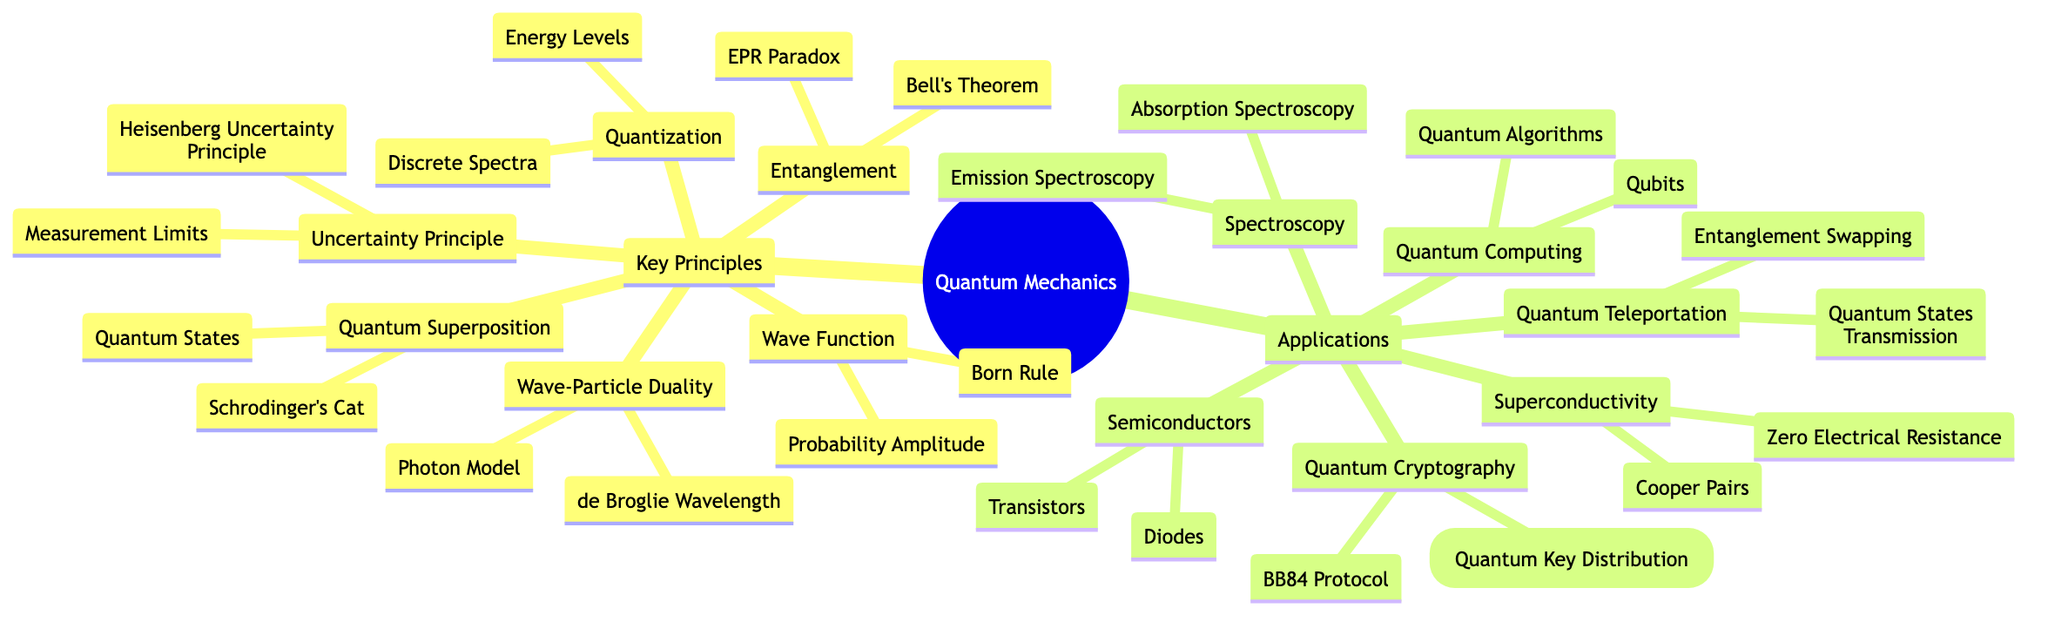What are the key principles of Quantum Mechanics? The top-level category of "Key Principles" includes six distinct principles: Wave-Particle Duality, Uncertainty Principle, Quantum Superposition, Quantization, Entanglement, and Wave Function.
Answer: Wave-Particle Duality, Uncertainty Principle, Quantum Superposition, Quantization, Entanglement, Wave Function How many applications are listed under Quantum Mechanics? The applications can be counted under the "Applications" section. There are six applications mentioned, which are Quantum Computing, Quantum Cryptography, Quantum Teleportation, Semiconductors, Superconductivity, and Spectroscopy.
Answer: Six What is the relationship between Quantum Teleportation and Entanglement? In the diagram, Quantum Teleportation is categorized as an application of Quantum Mechanics, and one of its components is entitled "Entanglement Swapping," which shows that entanglement plays a role in the process of quantum teleportation.
Answer: Related through Entanglement Swapping Which principle relates to the concept of Schrodinger's Cat? Schrodinger's Cat is categorized as a component under the principle of Quantum Superposition, thus connecting this famous thought experiment to the concept of superposition in quantum mechanics.
Answer: Quantum Superposition What are the two components of Quantum Cryptography? Under the Applications section, Quantum Cryptography has two components listed: QKD (Quantum Key Distribution) and BB84 Protocol.
Answer: QKD, BB84 Protocol What is the principle associated with the Heisenberg Uncertainty Principle? The Heisenberg Uncertainty Principle is explicitly listed under the Key Principles category, indicating it's one of the foundational concepts in Quantum Mechanics that deals with measurement limits and uncertainties.
Answer: Uncertainty Principle How many components are under Wave Function? The Wave Function principle contains two components mentioned: Born Rule and Probability Amplitude, which can be counted directly from the diagram.
Answer: Two What does the term 'Qubits' refer to in Quantum Computing? Qubits are part of the Quantum Computing section, indicating they function as the basic units of quantum information, much like classical bits in classical computing, which forms a fundamental aspect of quantum computing systems.
Answer: Basic unit of Quantum Computing What does Bell's Theorem relate to? Bell's Theorem is categorized under the principle of Entanglement, indicating that it addresses the nature of quantum entanglement and its implications regarding local hidden variables, central to discussions on quantum mechanics.
Answer: Entanglement 